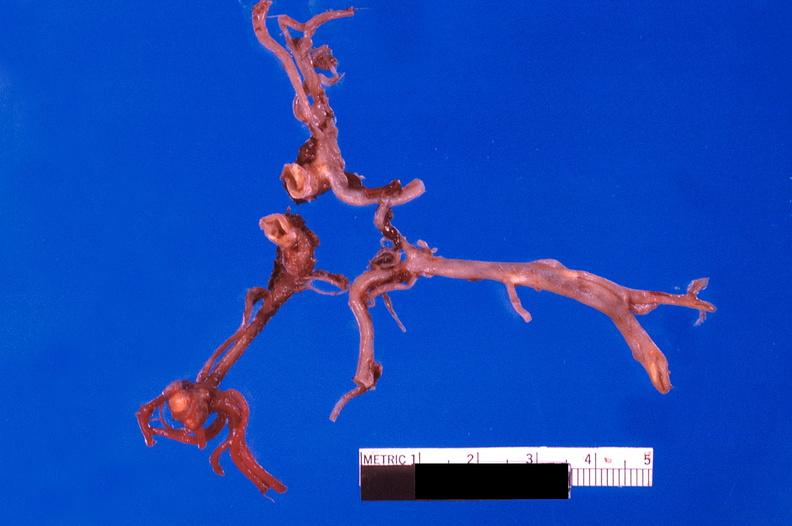does fibrinous peritonitis show ruptured saccular aneurysm right middle cerebral artery?
Answer the question using a single word or phrase. No 